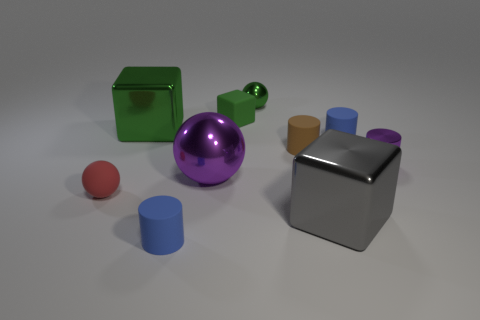Can you guess if the arrangement of these objects serves a particular purpose? From this still image, it's not clear if there's a specific functional purpose for the arrangement. It could represent a creative composition for artistic or illustrative purposes, potentially highlighting differences in shape, color, and size among everyday geometric forms. 